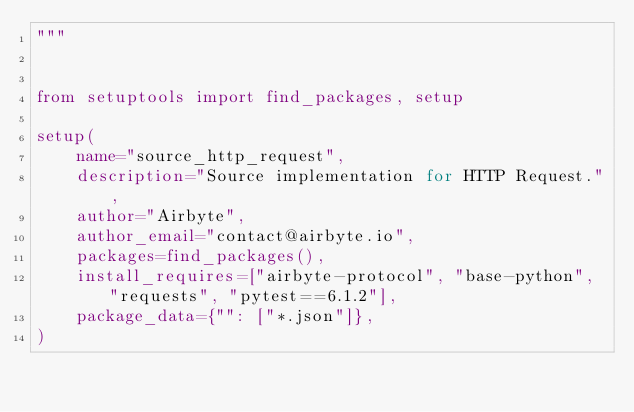Convert code to text. <code><loc_0><loc_0><loc_500><loc_500><_Python_>"""


from setuptools import find_packages, setup

setup(
    name="source_http_request",
    description="Source implementation for HTTP Request.",
    author="Airbyte",
    author_email="contact@airbyte.io",
    packages=find_packages(),
    install_requires=["airbyte-protocol", "base-python", "requests", "pytest==6.1.2"],
    package_data={"": ["*.json"]},
)
</code> 